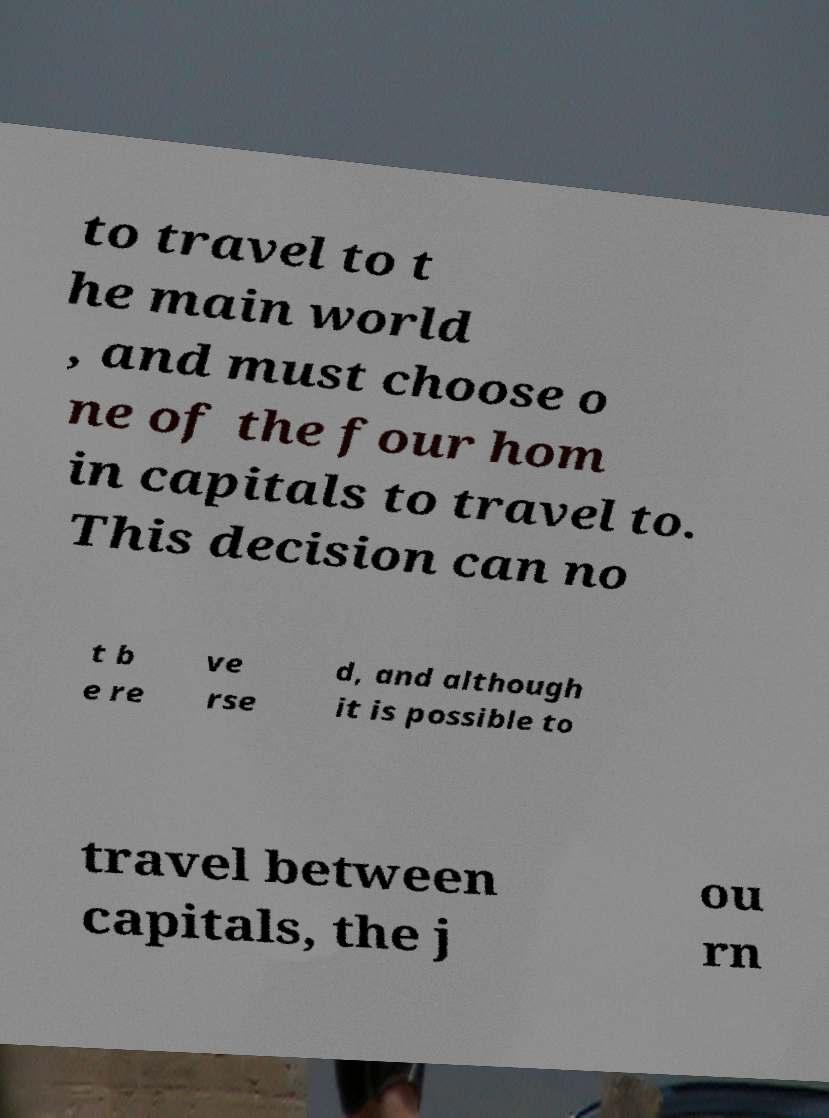There's text embedded in this image that I need extracted. Can you transcribe it verbatim? to travel to t he main world , and must choose o ne of the four hom in capitals to travel to. This decision can no t b e re ve rse d, and although it is possible to travel between capitals, the j ou rn 